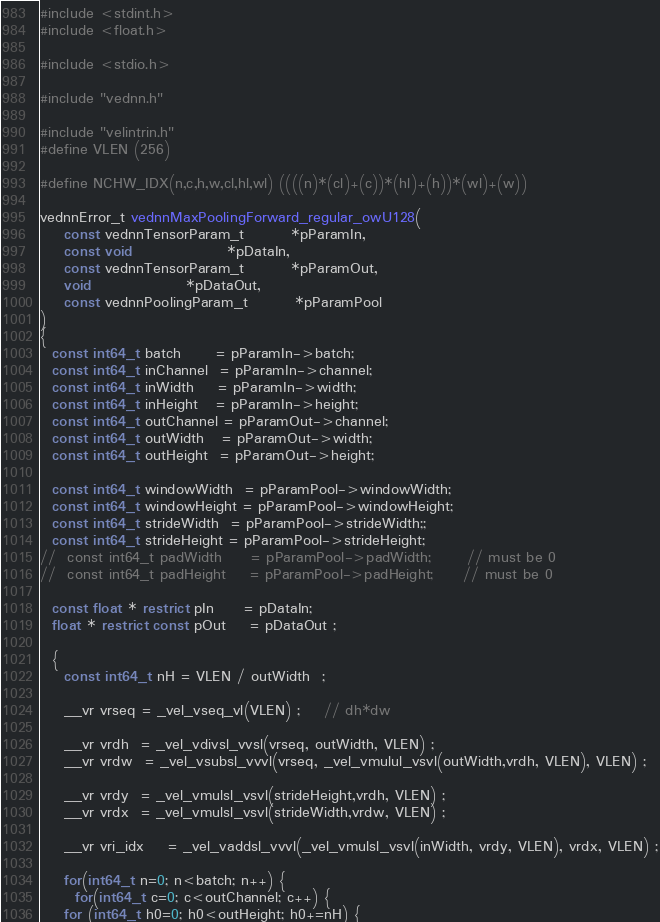Convert code to text. <code><loc_0><loc_0><loc_500><loc_500><_C_>#include <stdint.h>
#include <float.h>

#include <stdio.h>

#include "vednn.h"

#include "velintrin.h"
#define VLEN	(256)

#define NCHW_IDX(n,c,h,w,cl,hl,wl) ((((n)*(cl)+(c))*(hl)+(h))*(wl)+(w))

vednnError_t vednnMaxPoolingForward_regular_owU128(
    const vednnTensorParam_t 		*pParamIn,
    const void 				*pDataIn,
    const vednnTensorParam_t 		*pParamOut,
    void 				*pDataOut,
    const vednnPoolingParam_t		*pParamPool
)
{
  const int64_t batch      = pParamIn->batch;
  const int64_t inChannel  = pParamIn->channel;
  const int64_t inWidth    = pParamIn->width;
  const int64_t inHeight   = pParamIn->height;
  const int64_t outChannel = pParamOut->channel;
  const int64_t outWidth   = pParamOut->width;
  const int64_t outHeight  = pParamOut->height;

  const int64_t windowWidth  = pParamPool->windowWidth;
  const int64_t windowHeight = pParamPool->windowHeight;
  const int64_t strideWidth  = pParamPool->strideWidth;;
  const int64_t strideHeight = pParamPool->strideHeight;
//  const int64_t padWidth     = pParamPool->padWidth;		// must be 0
//  const int64_t padHeight    = pParamPool->padHeight;		// must be 0

  const float * restrict pIn     = pDataIn;
  float * restrict const pOut    = pDataOut ;

  {
    const int64_t nH = VLEN / outWidth  ;

    __vr vrseq = _vel_vseq_vl(VLEN) ;	// dh*dw

    __vr vrdh  = _vel_vdivsl_vvsl(vrseq, outWidth, VLEN) ;
    __vr vrdw  = _vel_vsubsl_vvvl(vrseq, _vel_vmulul_vsvl(outWidth,vrdh, VLEN), VLEN) ;

    __vr vrdy  = _vel_vmulsl_vsvl(strideHeight,vrdh, VLEN) ;
    __vr vrdx  = _vel_vmulsl_vsvl(strideWidth,vrdw, VLEN) ;

    __vr vri_idx    = _vel_vaddsl_vvvl(_vel_vmulsl_vsvl(inWidth, vrdy, VLEN), vrdx, VLEN) ;

    for(int64_t n=0; n<batch; n++) {
      for(int64_t c=0; c<outChannel; c++) {
	for (int64_t h0=0; h0<outHeight; h0+=nH) {</code> 